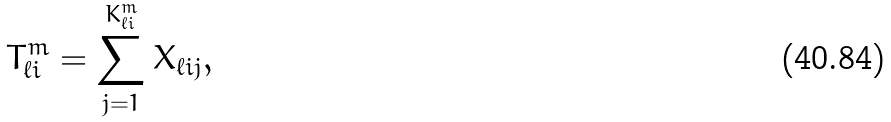<formula> <loc_0><loc_0><loc_500><loc_500>T _ { \ell i } ^ { m } = \sum _ { j = 1 } ^ { K _ { \ell i } ^ { m } } X _ { \ell i j } ,</formula> 